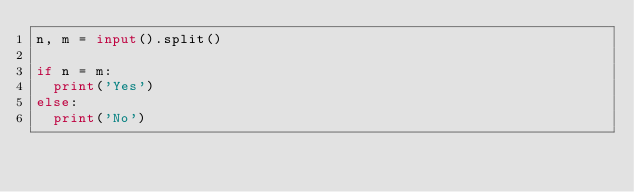Convert code to text. <code><loc_0><loc_0><loc_500><loc_500><_Python_>n, m = input().split()

if n = m:
  print('Yes')
else:
  print('No')</code> 